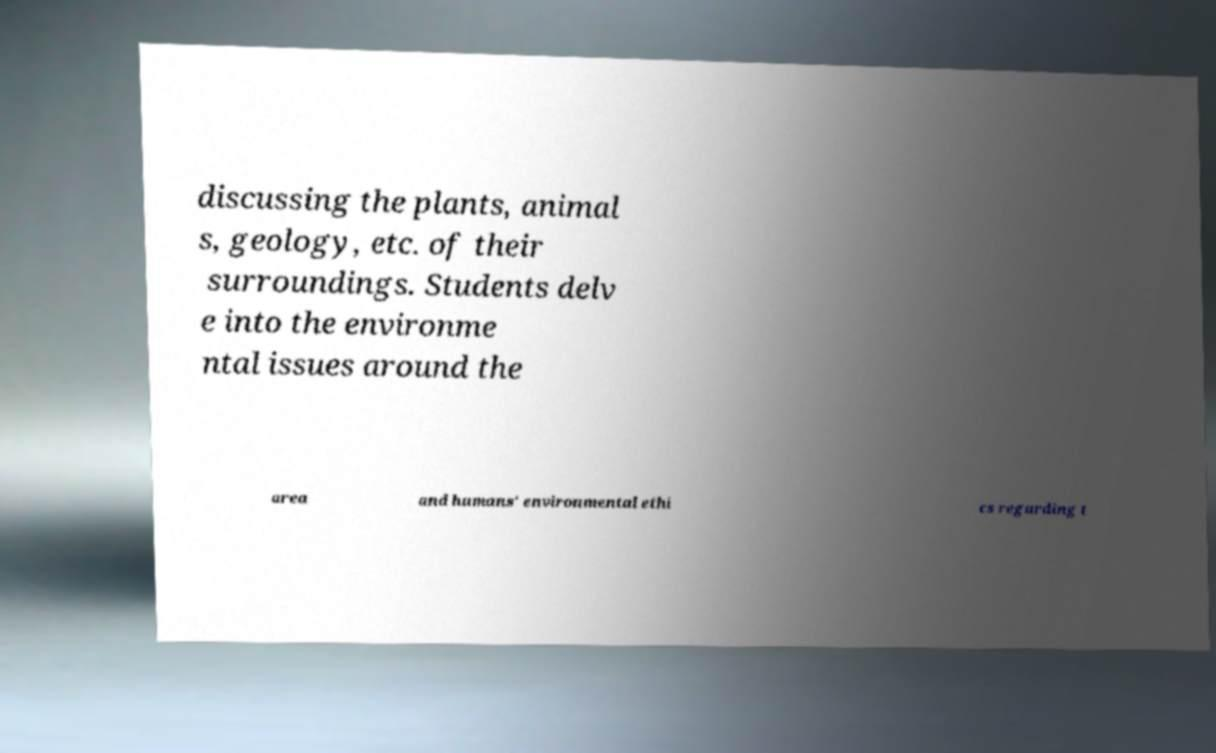Please identify and transcribe the text found in this image. discussing the plants, animal s, geology, etc. of their surroundings. Students delv e into the environme ntal issues around the area and humans' environmental ethi cs regarding t 